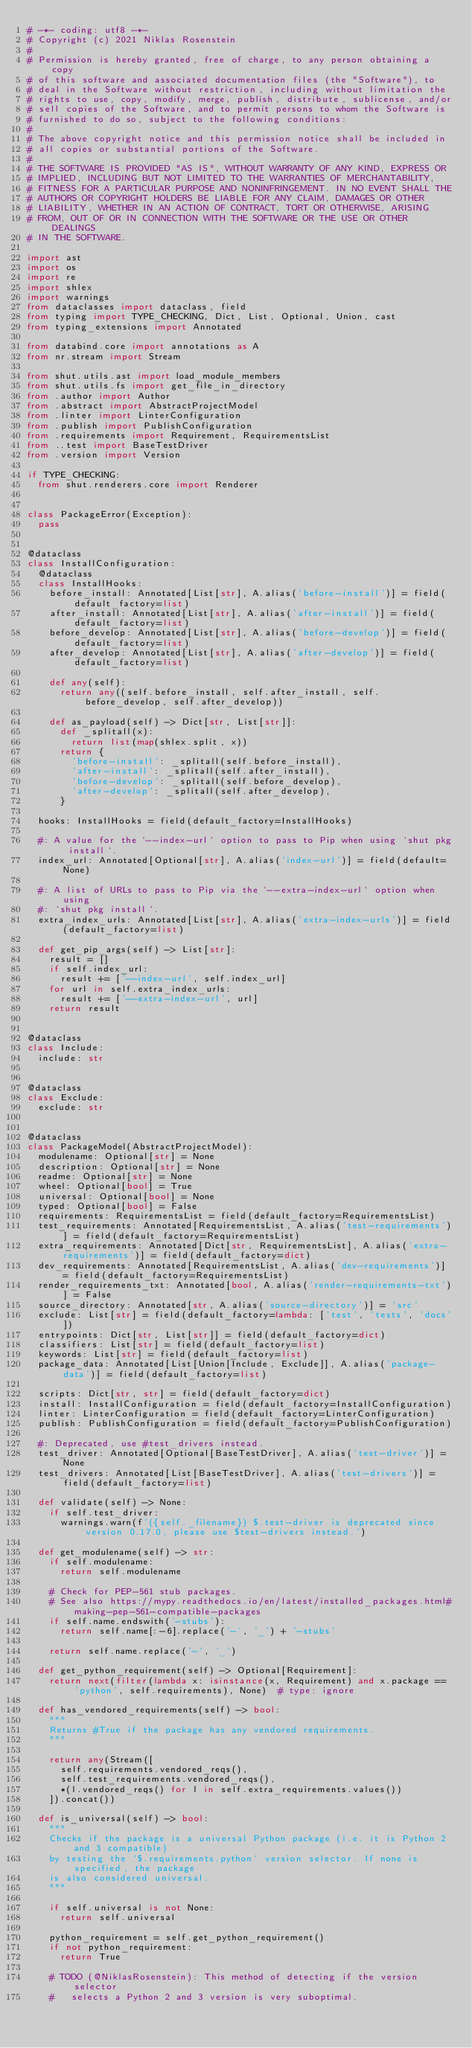<code> <loc_0><loc_0><loc_500><loc_500><_Python_># -*- coding: utf8 -*-
# Copyright (c) 2021 Niklas Rosenstein
#
# Permission is hereby granted, free of charge, to any person obtaining a copy
# of this software and associated documentation files (the "Software"), to
# deal in the Software without restriction, including without limitation the
# rights to use, copy, modify, merge, publish, distribute, sublicense, and/or
# sell copies of the Software, and to permit persons to whom the Software is
# furnished to do so, subject to the following conditions:
#
# The above copyright notice and this permission notice shall be included in
# all copies or substantial portions of the Software.
#
# THE SOFTWARE IS PROVIDED "AS IS", WITHOUT WARRANTY OF ANY KIND, EXPRESS OR
# IMPLIED, INCLUDING BUT NOT LIMITED TO THE WARRANTIES OF MERCHANTABILITY,
# FITNESS FOR A PARTICULAR PURPOSE AND NONINFRINGEMENT. IN NO EVENT SHALL THE
# AUTHORS OR COPYRIGHT HOLDERS BE LIABLE FOR ANY CLAIM, DAMAGES OR OTHER
# LIABILITY, WHETHER IN AN ACTION OF CONTRACT, TORT OR OTHERWISE, ARISING
# FROM, OUT OF OR IN CONNECTION WITH THE SOFTWARE OR THE USE OR OTHER DEALINGS
# IN THE SOFTWARE.

import ast
import os
import re
import shlex
import warnings
from dataclasses import dataclass, field
from typing import TYPE_CHECKING, Dict, List, Optional, Union, cast
from typing_extensions import Annotated

from databind.core import annotations as A
from nr.stream import Stream

from shut.utils.ast import load_module_members
from shut.utils.fs import get_file_in_directory
from .author import Author
from .abstract import AbstractProjectModel
from .linter import LinterConfiguration
from .publish import PublishConfiguration
from .requirements import Requirement, RequirementsList
from ..test import BaseTestDriver
from .version import Version

if TYPE_CHECKING:
  from shut.renderers.core import Renderer


class PackageError(Exception):
  pass


@dataclass
class InstallConfiguration:
  @dataclass
  class InstallHooks:
    before_install: Annotated[List[str], A.alias('before-install')] = field(default_factory=list)
    after_install: Annotated[List[str], A.alias('after-install')] = field(default_factory=list)
    before_develop: Annotated[List[str], A.alias('before-develop')] = field(default_factory=list)
    after_develop: Annotated[List[str], A.alias('after-develop')] = field(default_factory=list)

    def any(self):
      return any((self.before_install, self.after_install, self.before_develop, self.after_develop))

    def as_payload(self) -> Dict[str, List[str]]:
      def _splitall(x):
        return list(map(shlex.split, x))
      return {
        'before-install': _splitall(self.before_install),
        'after-install': _splitall(self.after_install),
        'before-develop': _splitall(self.before_develop),
        'after-develop': _splitall(self.after_develop),
      }

  hooks: InstallHooks = field(default_factory=InstallHooks)

  #: A value for the `--index-url` option to pass to Pip when using `shut pkg install`.
  index_url: Annotated[Optional[str], A.alias('index-url')] = field(default=None)

  #: A list of URLs to pass to Pip via the `--extra-index-url` option when using
  #: `shut pkg install`.
  extra_index_urls: Annotated[List[str], A.alias('extra-index-urls')] = field(default_factory=list)

  def get_pip_args(self) -> List[str]:
    result = []
    if self.index_url:
      result += ['--index-url', self.index_url]
    for url in self.extra_index_urls:
      result += ['--extra-index-url', url]
    return result


@dataclass
class Include:
  include: str


@dataclass
class Exclude:
  exclude: str


@dataclass
class PackageModel(AbstractProjectModel):
  modulename: Optional[str] = None
  description: Optional[str] = None
  readme: Optional[str] = None
  wheel: Optional[bool] = True
  universal: Optional[bool] = None
  typed: Optional[bool] = False
  requirements: RequirementsList = field(default_factory=RequirementsList)
  test_requirements: Annotated[RequirementsList, A.alias('test-requirements')] = field(default_factory=RequirementsList)
  extra_requirements: Annotated[Dict[str, RequirementsList], A.alias('extra-requirements')] = field(default_factory=dict)
  dev_requirements: Annotated[RequirementsList, A.alias('dev-requirements')] = field(default_factory=RequirementsList)
  render_requirements_txt: Annotated[bool, A.alias('render-requirements-txt')] = False
  source_directory: Annotated[str, A.alias('source-directory')] = 'src'
  exclude: List[str] = field(default_factory=lambda: ['test', 'tests', 'docs'])
  entrypoints: Dict[str, List[str]] = field(default_factory=dict)
  classifiers: List[str] = field(default_factory=list)
  keywords: List[str] = field(default_factory=list)
  package_data: Annotated[List[Union[Include, Exclude]], A.alias('package-data')] = field(default_factory=list)

  scripts: Dict[str, str] = field(default_factory=dict)
  install: InstallConfiguration = field(default_factory=InstallConfiguration)
  linter: LinterConfiguration = field(default_factory=LinterConfiguration)
  publish: PublishConfiguration = field(default_factory=PublishConfiguration)

  #: Deprecated, use #test_drivers instead.
  test_driver: Annotated[Optional[BaseTestDriver], A.alias('test-driver')] = None
  test_drivers: Annotated[List[BaseTestDriver], A.alias('test-drivers')] = field(default_factory=list)

  def validate(self) -> None:
    if self.test_driver:
      warnings.warn(f'({self._filename}) $.test-driver is deprecated since version 0.17.0, please use $test-drivers instead.')

  def get_modulename(self) -> str:
    if self.modulename:
      return self.modulename

    # Check for PEP-561 stub packages.
    # See also https://mypy.readthedocs.io/en/latest/installed_packages.html#making-pep-561-compatible-packages
    if self.name.endswith('-stubs'):
      return self.name[:-6].replace('-', '_') + '-stubs'

    return self.name.replace('-', '_')

  def get_python_requirement(self) -> Optional[Requirement]:
    return next(filter(lambda x: isinstance(x, Requirement) and x.package == 'python', self.requirements), None)  # type: ignore

  def has_vendored_requirements(self) -> bool:
    """
    Returns #True if the package has any vendored requirements.
    """

    return any(Stream([
      self.requirements.vendored_reqs(),
      self.test_requirements.vendored_reqs(),
      *(l.vendored_reqs() for l in self.extra_requirements.values())
    ]).concat())

  def is_universal(self) -> bool:
    """
    Checks if the package is a universal Python package (i.e. it is Python 2 and 3 compatible)
    by testing the `$.requirements.python` version selector. If none is specified, the package
    is also considered universal.
    """

    if self.universal is not None:
      return self.universal

    python_requirement = self.get_python_requirement()
    if not python_requirement:
      return True

    # TODO (@NiklasRosenstein): This method of detecting if the version selector
    #   selects a Python 2 and 3 version is very suboptimal.</code> 